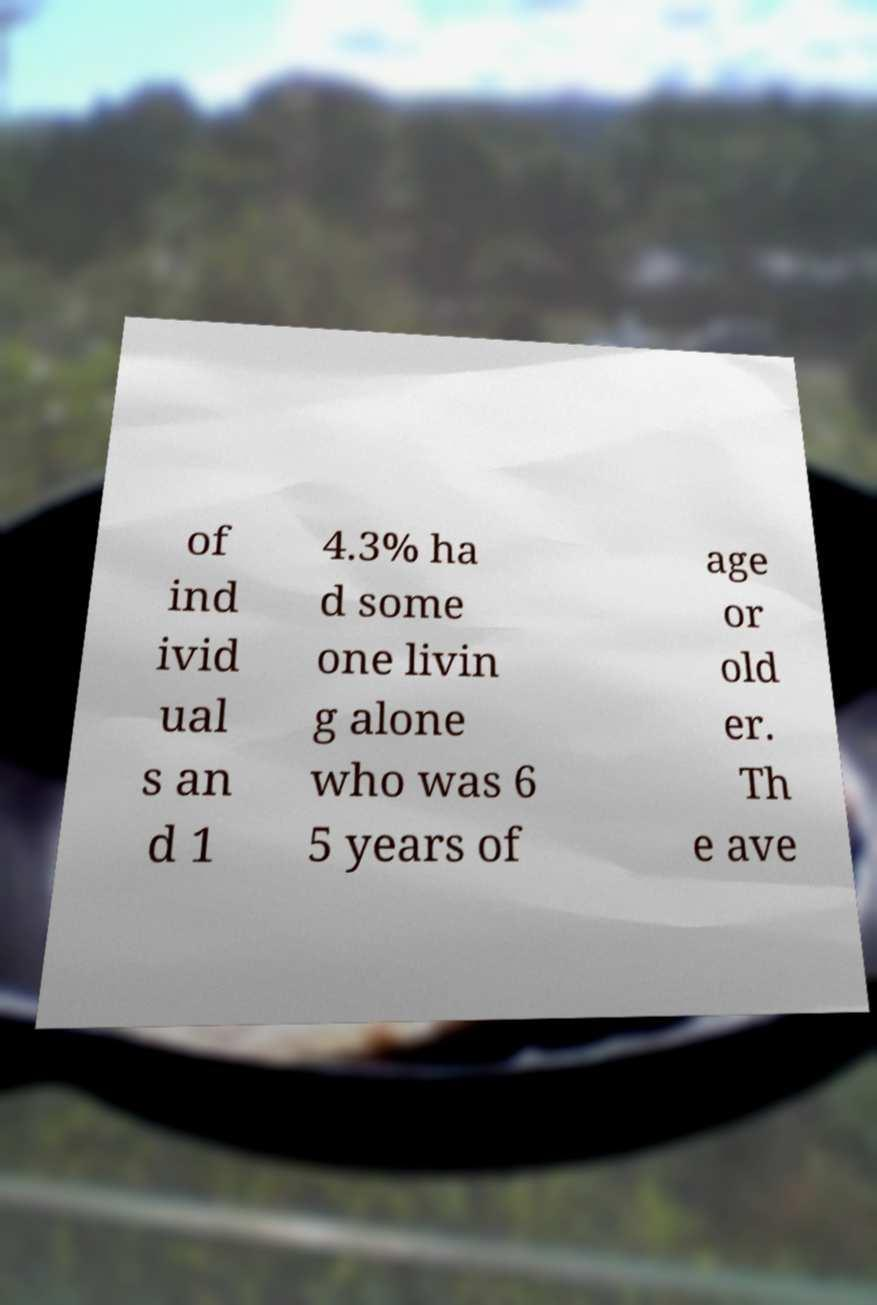Please read and relay the text visible in this image. What does it say? of ind ivid ual s an d 1 4.3% ha d some one livin g alone who was 6 5 years of age or old er. Th e ave 